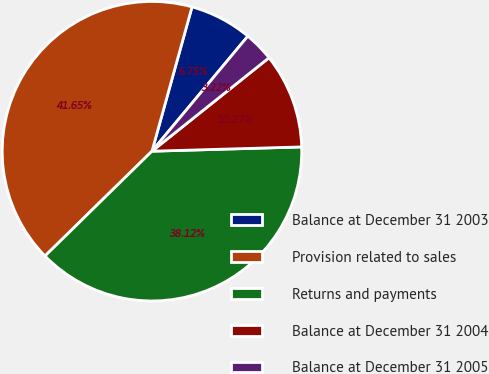<chart> <loc_0><loc_0><loc_500><loc_500><pie_chart><fcel>Balance at December 31 2003<fcel>Provision related to sales<fcel>Returns and payments<fcel>Balance at December 31 2004<fcel>Balance at December 31 2005<nl><fcel>6.75%<fcel>41.65%<fcel>38.12%<fcel>10.27%<fcel>3.22%<nl></chart> 